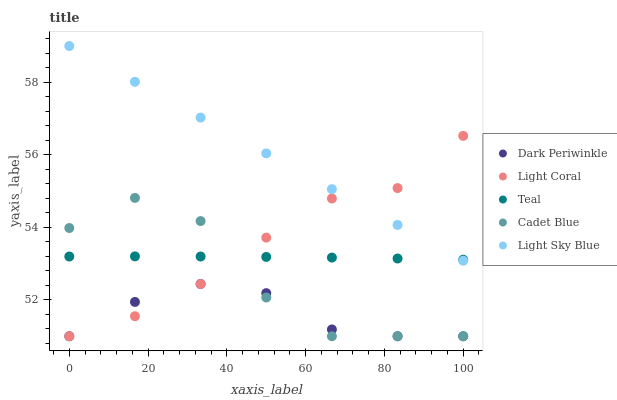Does Dark Periwinkle have the minimum area under the curve?
Answer yes or no. Yes. Does Light Sky Blue have the maximum area under the curve?
Answer yes or no. Yes. Does Cadet Blue have the minimum area under the curve?
Answer yes or no. No. Does Cadet Blue have the maximum area under the curve?
Answer yes or no. No. Is Light Sky Blue the smoothest?
Answer yes or no. Yes. Is Cadet Blue the roughest?
Answer yes or no. Yes. Is Dark Periwinkle the smoothest?
Answer yes or no. No. Is Dark Periwinkle the roughest?
Answer yes or no. No. Does Light Coral have the lowest value?
Answer yes or no. Yes. Does Teal have the lowest value?
Answer yes or no. No. Does Light Sky Blue have the highest value?
Answer yes or no. Yes. Does Cadet Blue have the highest value?
Answer yes or no. No. Is Dark Periwinkle less than Teal?
Answer yes or no. Yes. Is Light Sky Blue greater than Cadet Blue?
Answer yes or no. Yes. Does Teal intersect Light Sky Blue?
Answer yes or no. Yes. Is Teal less than Light Sky Blue?
Answer yes or no. No. Is Teal greater than Light Sky Blue?
Answer yes or no. No. Does Dark Periwinkle intersect Teal?
Answer yes or no. No. 